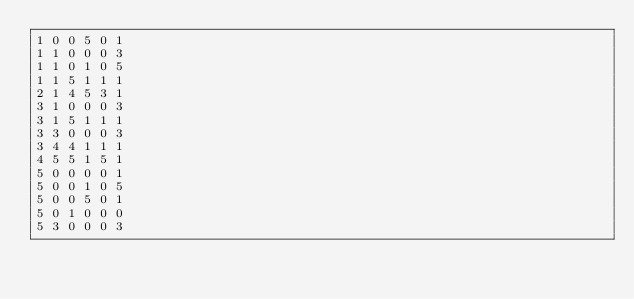Convert code to text. <code><loc_0><loc_0><loc_500><loc_500><_SQL_>1 0 0 5 0 1
1 1 0 0 0 3
1 1 0 1 0 5
1 1 5 1 1 1
2 1 4 5 3 1
3 1 0 0 0 3
3 1 5 1 1 1
3 3 0 0 0 3
3 4 4 1 1 1
4 5 5 1 5 1
5 0 0 0 0 1
5 0 0 1 0 5
5 0 0 5 0 1
5 0 1 0 0 0
5 3 0 0 0 3
</code> 